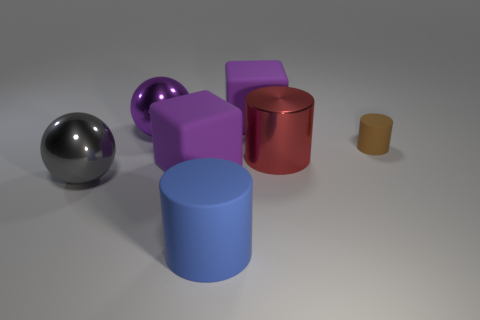There is a thing that is both on the right side of the large purple shiny ball and on the left side of the blue cylinder; what shape is it?
Your response must be concise. Cube. How many things are either gray metallic spheres or large things behind the large gray metal ball?
Keep it short and to the point. 5. There is a red object that is the same shape as the brown matte object; what is it made of?
Your response must be concise. Metal. The thing that is in front of the red metal cylinder and behind the gray metal ball is made of what material?
Your answer should be very brief. Rubber. How many other things are the same shape as the small brown thing?
Your answer should be compact. 2. What is the color of the large object that is behind the shiny sphere on the right side of the large gray ball?
Keep it short and to the point. Purple. Are there an equal number of purple balls to the left of the large gray object and gray rubber balls?
Your answer should be very brief. Yes. Is there a yellow matte cube of the same size as the red metal cylinder?
Your answer should be very brief. No. Does the purple metal ball have the same size as the cube behind the metal cylinder?
Ensure brevity in your answer.  Yes. Are there the same number of cylinders to the right of the big red cylinder and large cubes that are in front of the purple metal object?
Your response must be concise. Yes. 